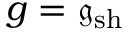Convert formula to latex. <formula><loc_0><loc_0><loc_500><loc_500>g = \mathfrak { g } _ { s h }</formula> 